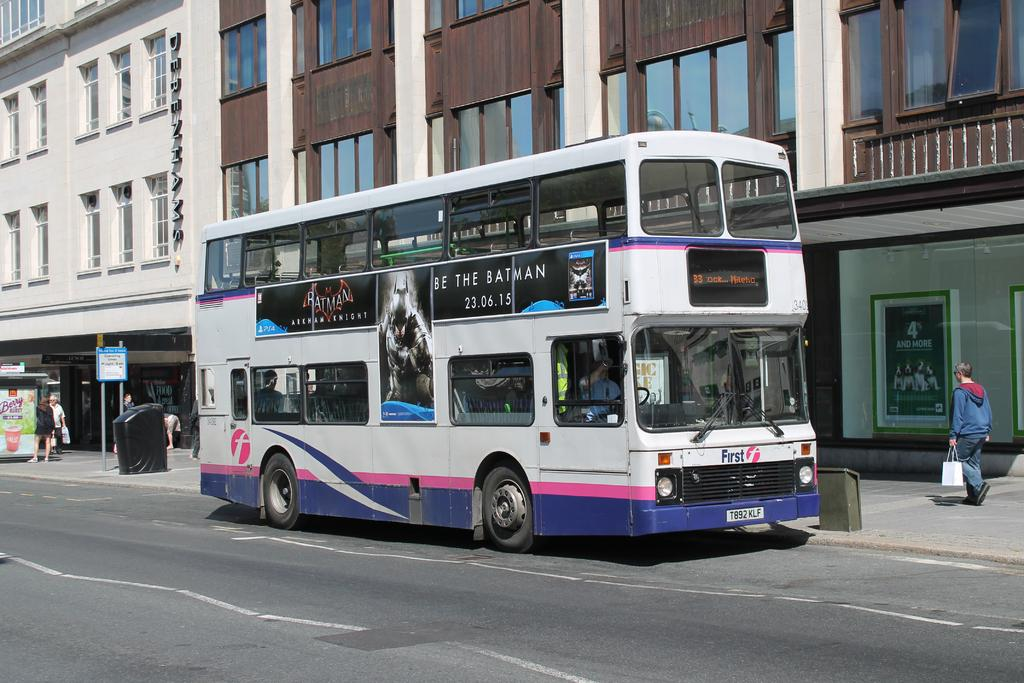<image>
Share a concise interpretation of the image provided. A white, pink and purple double decker bus with license plate T892 KLF 